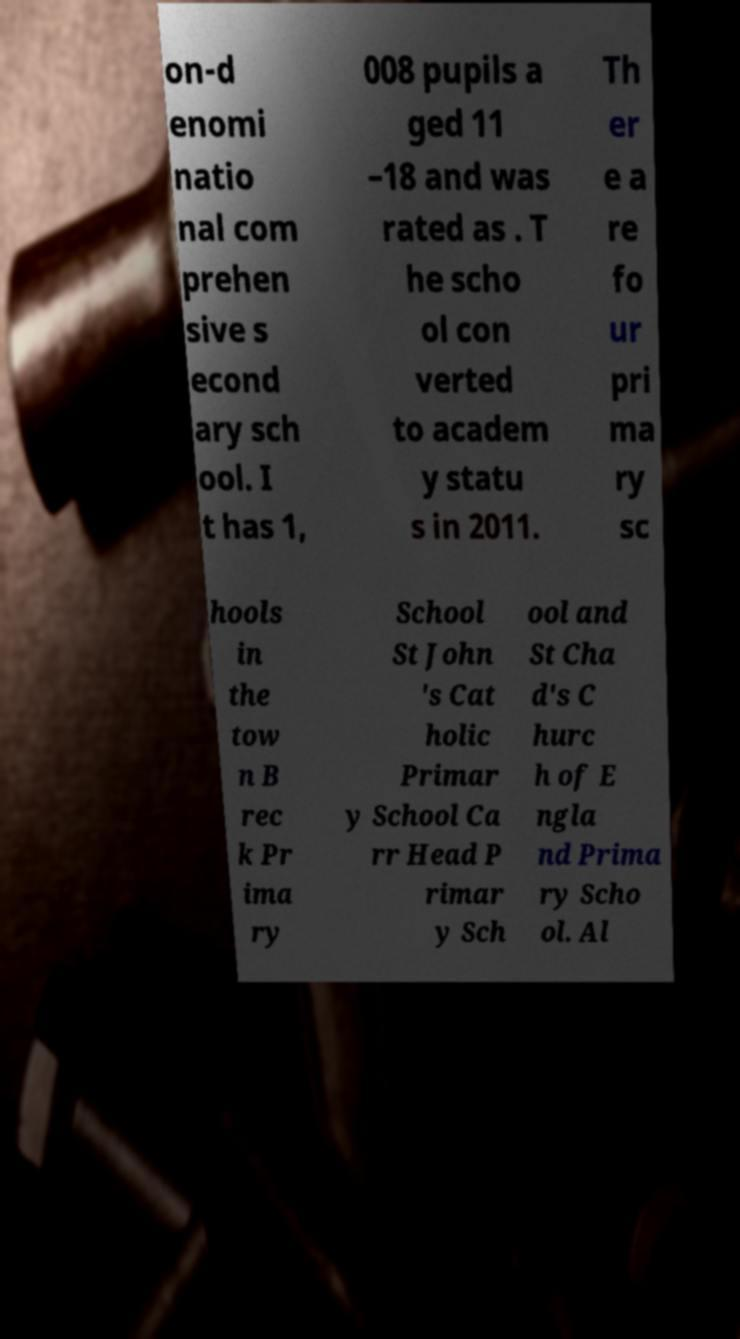What messages or text are displayed in this image? I need them in a readable, typed format. on-d enomi natio nal com prehen sive s econd ary sch ool. I t has 1, 008 pupils a ged 11 –18 and was rated as . T he scho ol con verted to academ y statu s in 2011. Th er e a re fo ur pri ma ry sc hools in the tow n B rec k Pr ima ry School St John 's Cat holic Primar y School Ca rr Head P rimar y Sch ool and St Cha d's C hurc h of E ngla nd Prima ry Scho ol. Al 